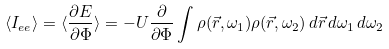Convert formula to latex. <formula><loc_0><loc_0><loc_500><loc_500>\langle I _ { e e } \rangle = \langle \frac { \partial E } { \partial \Phi } \rangle = - { U } \frac { \partial } { \partial \Phi } \int \rho ( \vec { r } , \omega _ { 1 } ) \rho ( \vec { r } , \omega _ { 2 } ) \, d \vec { r } \, d \omega _ { 1 } \, d \omega _ { 2 }</formula> 